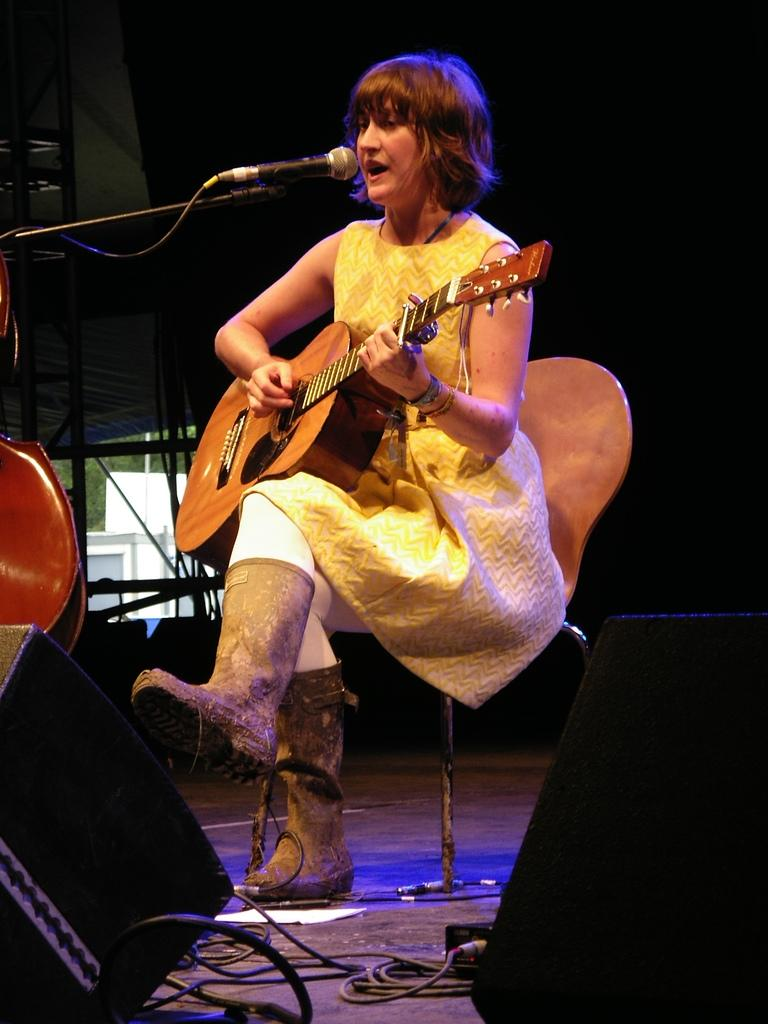What is the main subject of the image? There is a person in the image. What is the person doing in the image? The person is sitting in the image. What object is in front of the person? The person is in front of a mic. What is the person holding in the image? The person is holding a guitar. What type of soup is the person eating in the image? There is no soup present in the image; the person is holding a guitar and sitting in front of a mic. 